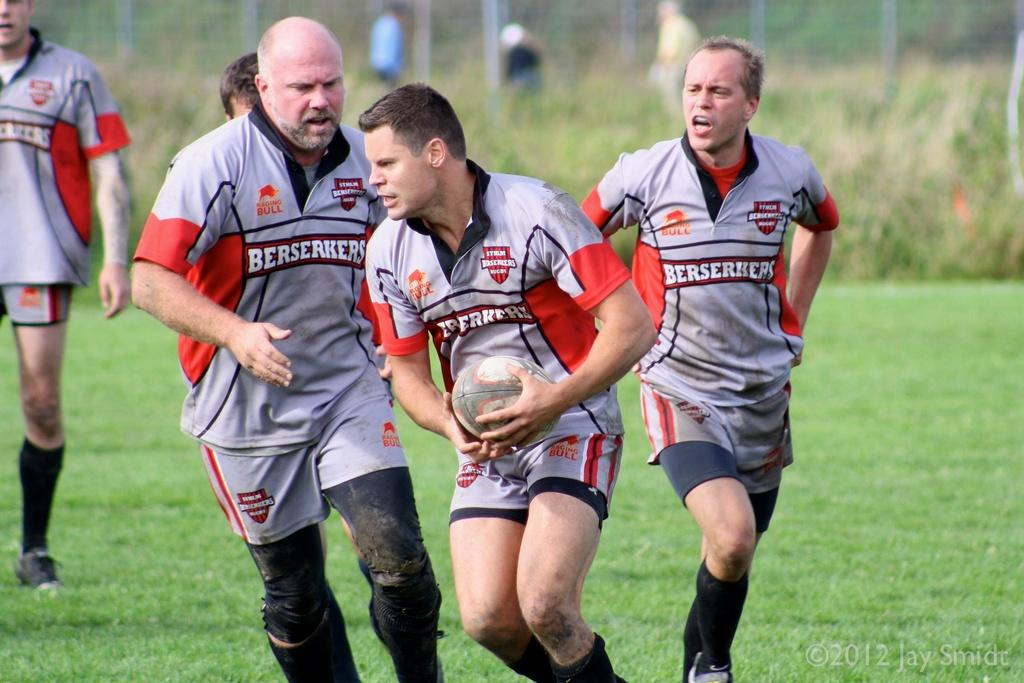How many people are in the image? There is a group of persons standing in the image, along with another person, making a total of at least two people. What is the person holding in the image? The person is holding a ball. What can be seen in the background of the image? There is grass and plants in the background of the image. What type of potato is being used as a question in the image? There is no potato or any reference to a question present in the image. 